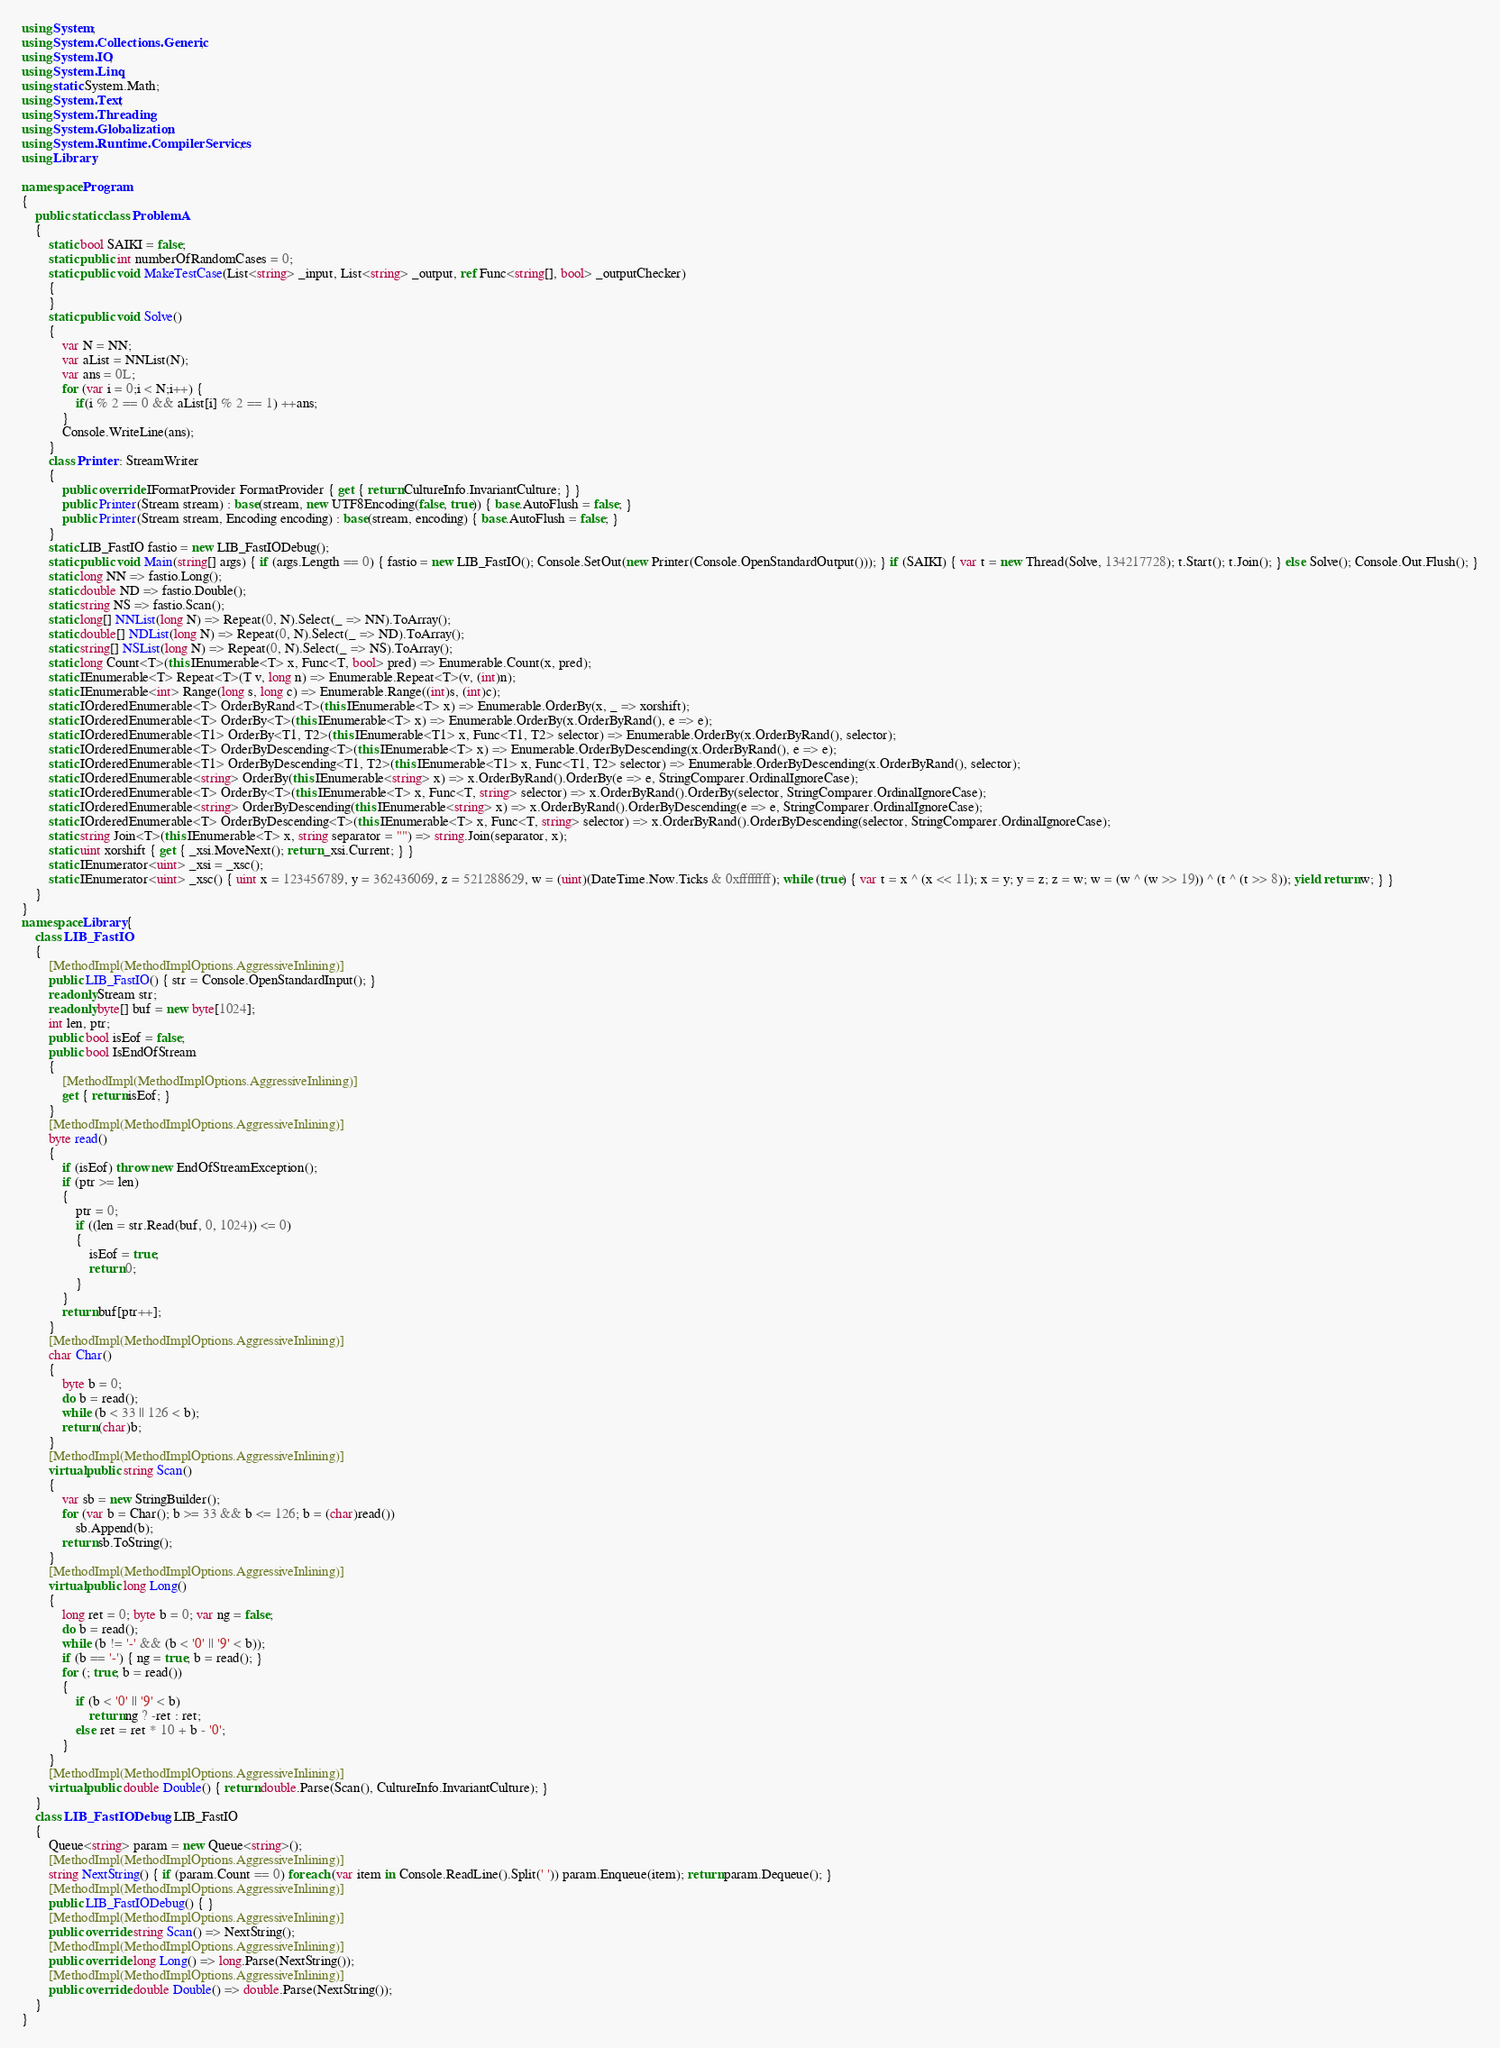<code> <loc_0><loc_0><loc_500><loc_500><_C#_>using System;
using System.Collections.Generic;
using System.IO;
using System.Linq;
using static System.Math;
using System.Text;
using System.Threading;
using System.Globalization;
using System.Runtime.CompilerServices;
using Library;

namespace Program
{
    public static class ProblemA
    {
        static bool SAIKI = false;
        static public int numberOfRandomCases = 0;
        static public void MakeTestCase(List<string> _input, List<string> _output, ref Func<string[], bool> _outputChecker)
        {
        }
        static public void Solve()
        {
            var N = NN;
            var aList = NNList(N);
            var ans = 0L;
            for (var i = 0;i < N;i++) {
                if(i % 2 == 0 && aList[i] % 2 == 1) ++ans;
            }
            Console.WriteLine(ans);
        }
        class Printer : StreamWriter
        {
            public override IFormatProvider FormatProvider { get { return CultureInfo.InvariantCulture; } }
            public Printer(Stream stream) : base(stream, new UTF8Encoding(false, true)) { base.AutoFlush = false; }
            public Printer(Stream stream, Encoding encoding) : base(stream, encoding) { base.AutoFlush = false; }
        }
        static LIB_FastIO fastio = new LIB_FastIODebug();
        static public void Main(string[] args) { if (args.Length == 0) { fastio = new LIB_FastIO(); Console.SetOut(new Printer(Console.OpenStandardOutput())); } if (SAIKI) { var t = new Thread(Solve, 134217728); t.Start(); t.Join(); } else Solve(); Console.Out.Flush(); }
        static long NN => fastio.Long();
        static double ND => fastio.Double();
        static string NS => fastio.Scan();
        static long[] NNList(long N) => Repeat(0, N).Select(_ => NN).ToArray();
        static double[] NDList(long N) => Repeat(0, N).Select(_ => ND).ToArray();
        static string[] NSList(long N) => Repeat(0, N).Select(_ => NS).ToArray();
        static long Count<T>(this IEnumerable<T> x, Func<T, bool> pred) => Enumerable.Count(x, pred);
        static IEnumerable<T> Repeat<T>(T v, long n) => Enumerable.Repeat<T>(v, (int)n);
        static IEnumerable<int> Range(long s, long c) => Enumerable.Range((int)s, (int)c);
        static IOrderedEnumerable<T> OrderByRand<T>(this IEnumerable<T> x) => Enumerable.OrderBy(x, _ => xorshift);
        static IOrderedEnumerable<T> OrderBy<T>(this IEnumerable<T> x) => Enumerable.OrderBy(x.OrderByRand(), e => e);
        static IOrderedEnumerable<T1> OrderBy<T1, T2>(this IEnumerable<T1> x, Func<T1, T2> selector) => Enumerable.OrderBy(x.OrderByRand(), selector);
        static IOrderedEnumerable<T> OrderByDescending<T>(this IEnumerable<T> x) => Enumerable.OrderByDescending(x.OrderByRand(), e => e);
        static IOrderedEnumerable<T1> OrderByDescending<T1, T2>(this IEnumerable<T1> x, Func<T1, T2> selector) => Enumerable.OrderByDescending(x.OrderByRand(), selector);
        static IOrderedEnumerable<string> OrderBy(this IEnumerable<string> x) => x.OrderByRand().OrderBy(e => e, StringComparer.OrdinalIgnoreCase);
        static IOrderedEnumerable<T> OrderBy<T>(this IEnumerable<T> x, Func<T, string> selector) => x.OrderByRand().OrderBy(selector, StringComparer.OrdinalIgnoreCase);
        static IOrderedEnumerable<string> OrderByDescending(this IEnumerable<string> x) => x.OrderByRand().OrderByDescending(e => e, StringComparer.OrdinalIgnoreCase);
        static IOrderedEnumerable<T> OrderByDescending<T>(this IEnumerable<T> x, Func<T, string> selector) => x.OrderByRand().OrderByDescending(selector, StringComparer.OrdinalIgnoreCase);
        static string Join<T>(this IEnumerable<T> x, string separator = "") => string.Join(separator, x);
        static uint xorshift { get { _xsi.MoveNext(); return _xsi.Current; } }
        static IEnumerator<uint> _xsi = _xsc();
        static IEnumerator<uint> _xsc() { uint x = 123456789, y = 362436069, z = 521288629, w = (uint)(DateTime.Now.Ticks & 0xffffffff); while (true) { var t = x ^ (x << 11); x = y; y = z; z = w; w = (w ^ (w >> 19)) ^ (t ^ (t >> 8)); yield return w; } }
    }
}
namespace Library {
    class LIB_FastIO
    {
        [MethodImpl(MethodImplOptions.AggressiveInlining)]
        public LIB_FastIO() { str = Console.OpenStandardInput(); }
        readonly Stream str;
        readonly byte[] buf = new byte[1024];
        int len, ptr;
        public bool isEof = false;
        public bool IsEndOfStream
        {
            [MethodImpl(MethodImplOptions.AggressiveInlining)]
            get { return isEof; }
        }
        [MethodImpl(MethodImplOptions.AggressiveInlining)]
        byte read()
        {
            if (isEof) throw new EndOfStreamException();
            if (ptr >= len)
            {
                ptr = 0;
                if ((len = str.Read(buf, 0, 1024)) <= 0)
                {
                    isEof = true;
                    return 0;
                }
            }
            return buf[ptr++];
        }
        [MethodImpl(MethodImplOptions.AggressiveInlining)]
        char Char()
        {
            byte b = 0;
            do b = read();
            while (b < 33 || 126 < b);
            return (char)b;
        }
        [MethodImpl(MethodImplOptions.AggressiveInlining)]
        virtual public string Scan()
        {
            var sb = new StringBuilder();
            for (var b = Char(); b >= 33 && b <= 126; b = (char)read())
                sb.Append(b);
            return sb.ToString();
        }
        [MethodImpl(MethodImplOptions.AggressiveInlining)]
        virtual public long Long()
        {
            long ret = 0; byte b = 0; var ng = false;
            do b = read();
            while (b != '-' && (b < '0' || '9' < b));
            if (b == '-') { ng = true; b = read(); }
            for (; true; b = read())
            {
                if (b < '0' || '9' < b)
                    return ng ? -ret : ret;
                else ret = ret * 10 + b - '0';
            }
        }
        [MethodImpl(MethodImplOptions.AggressiveInlining)]
        virtual public double Double() { return double.Parse(Scan(), CultureInfo.InvariantCulture); }
    }
    class LIB_FastIODebug : LIB_FastIO
    {
        Queue<string> param = new Queue<string>();
        [MethodImpl(MethodImplOptions.AggressiveInlining)]
        string NextString() { if (param.Count == 0) foreach (var item in Console.ReadLine().Split(' ')) param.Enqueue(item); return param.Dequeue(); }
        [MethodImpl(MethodImplOptions.AggressiveInlining)]
        public LIB_FastIODebug() { }
        [MethodImpl(MethodImplOptions.AggressiveInlining)]
        public override string Scan() => NextString();
        [MethodImpl(MethodImplOptions.AggressiveInlining)]
        public override long Long() => long.Parse(NextString());
        [MethodImpl(MethodImplOptions.AggressiveInlining)]
        public override double Double() => double.Parse(NextString());
    }
}
</code> 